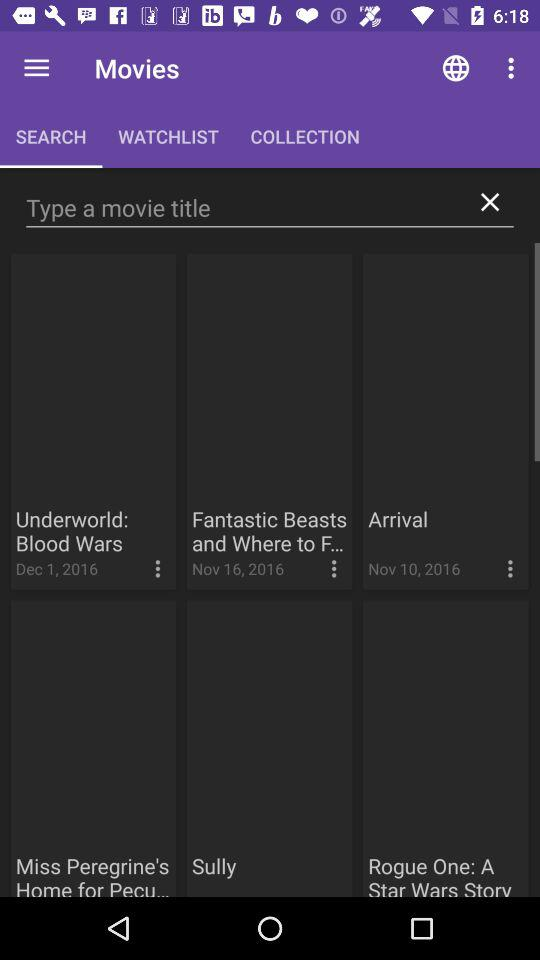What is the release date of the "Underworld: Blood Wars" movie? The release date is December 1, 2016. 